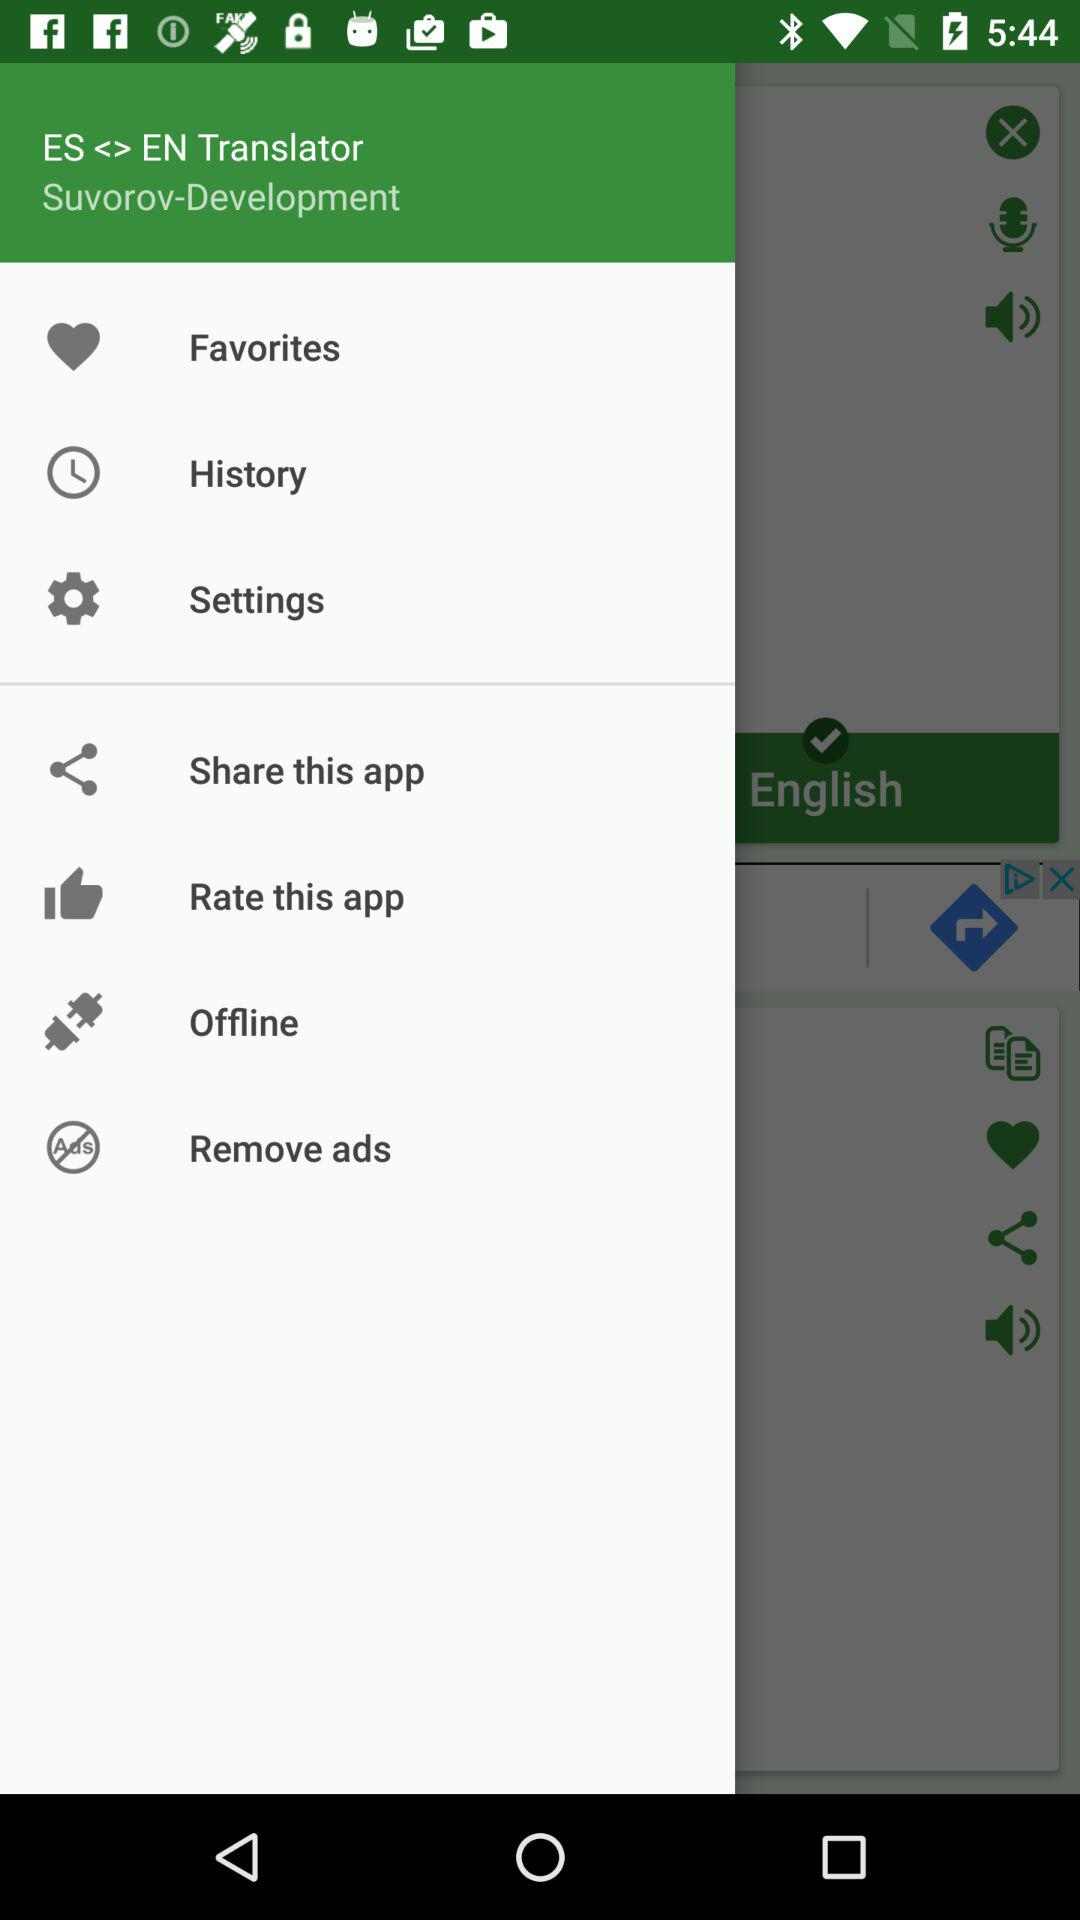How many notifications are there in "Settings"?
When the provided information is insufficient, respond with <no answer>. <no answer> 